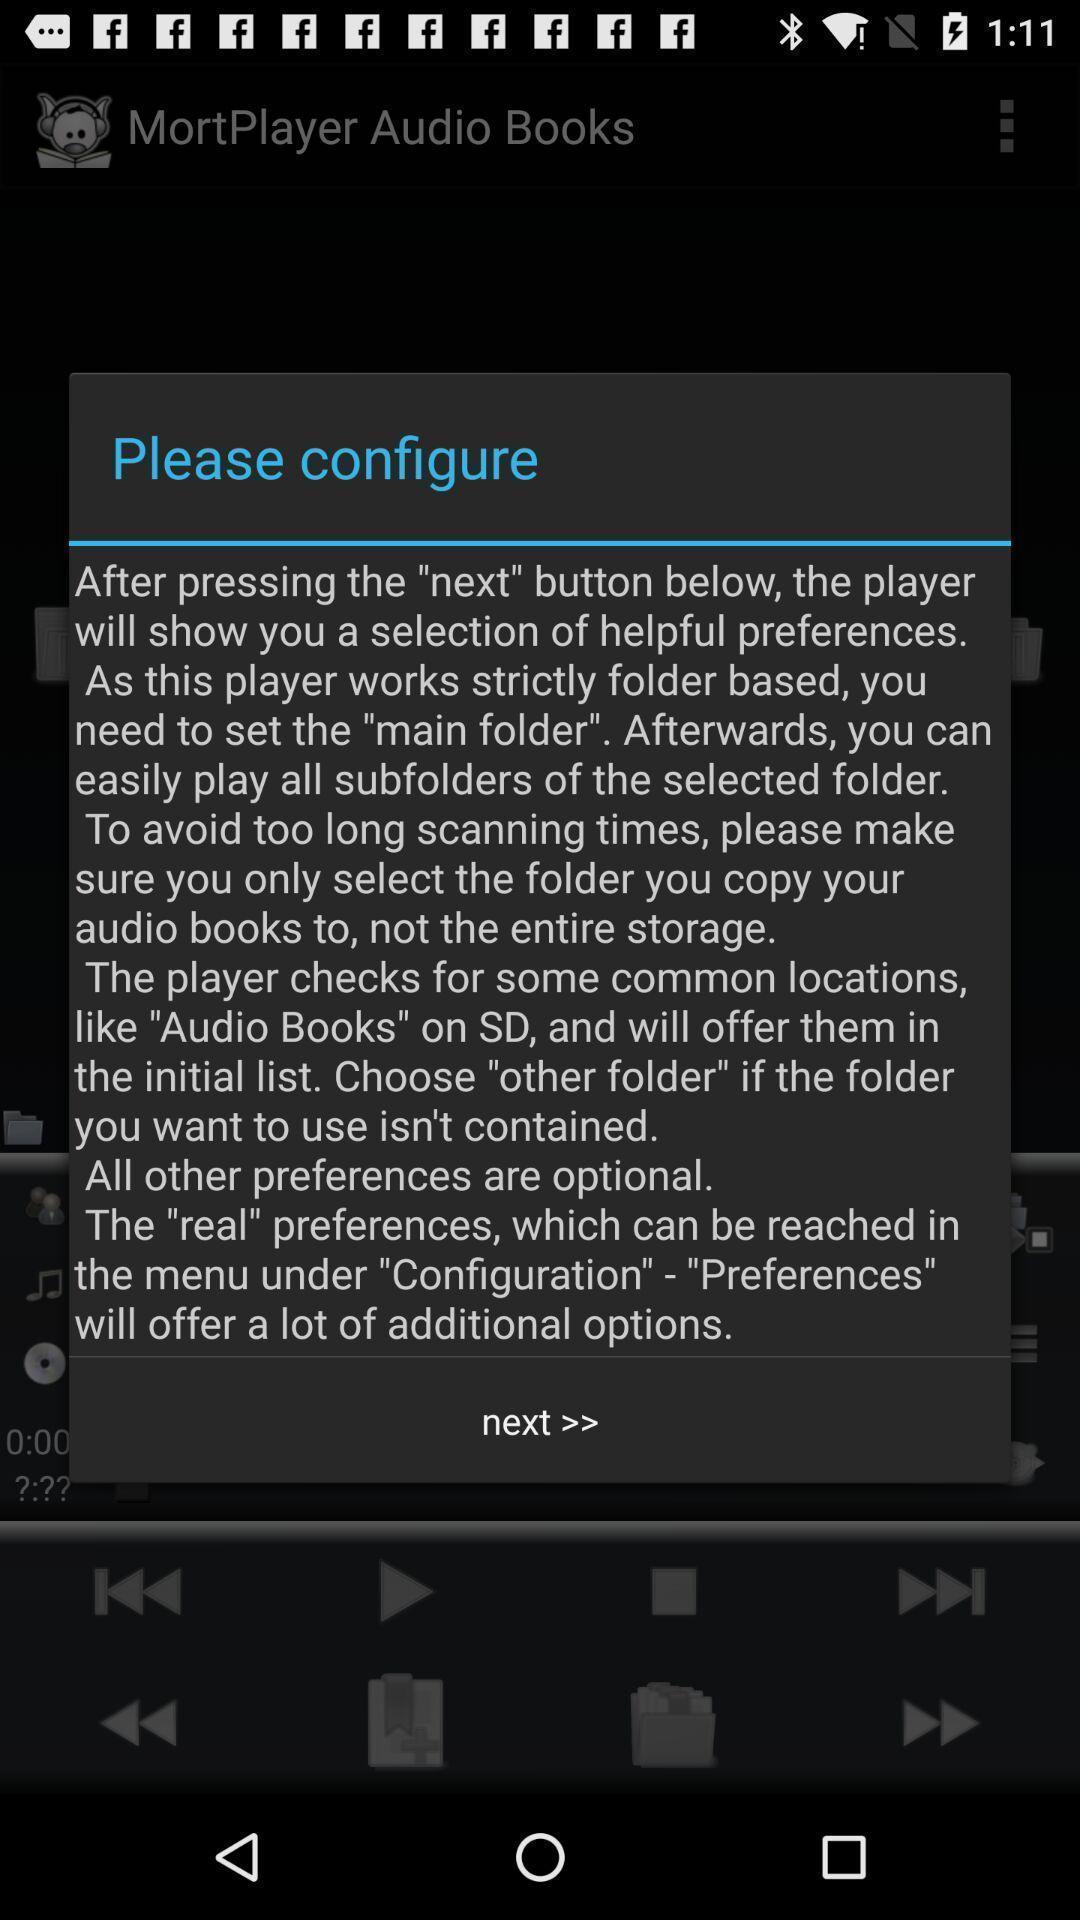Explain what's happening in this screen capture. Popup showing about information with next option. 